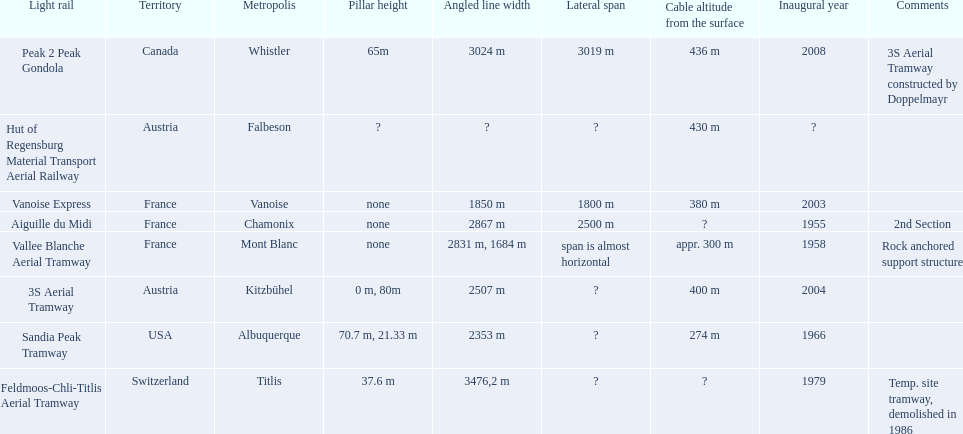When was the aiguille du midi tramway inaugurated? 1955. When was the 3s aerial tramway inaugurated? 2004. Which one was inaugurated first? Aiguille du Midi. 